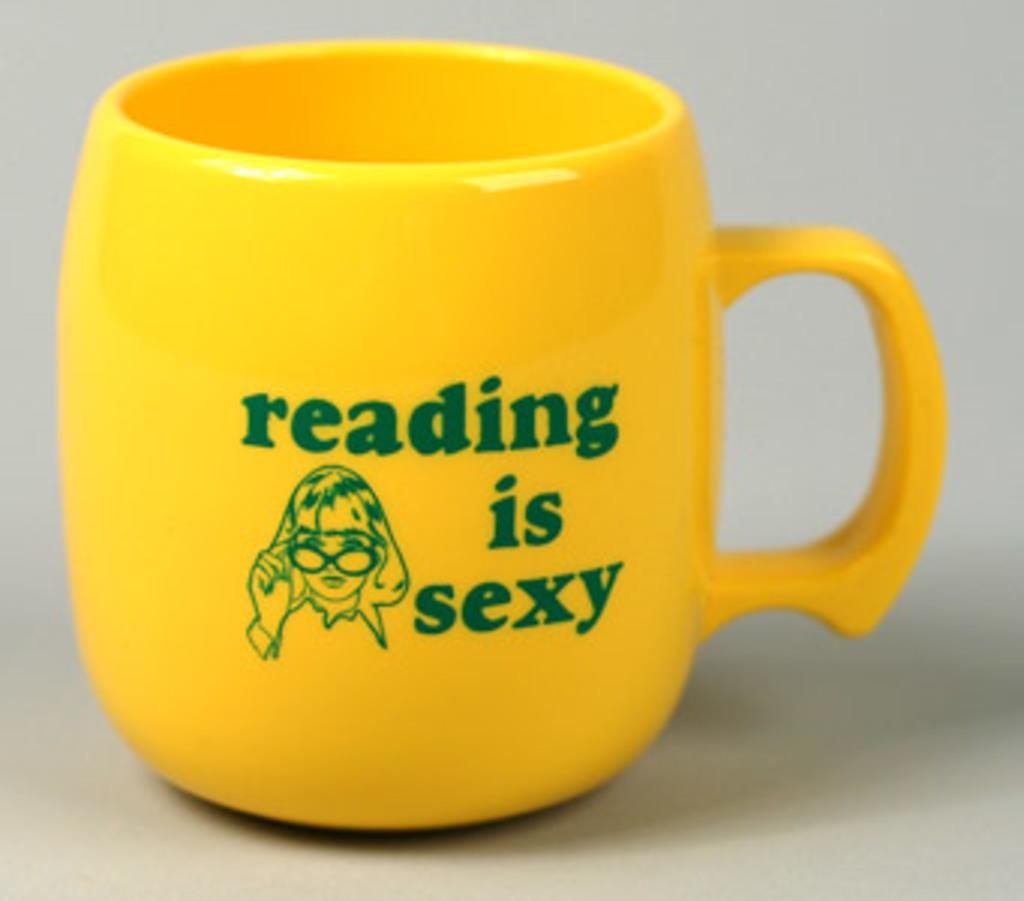<image>
Provide a brief description of the given image. A yellow coffee mug owned by somebody who thinks reading is sexy. 